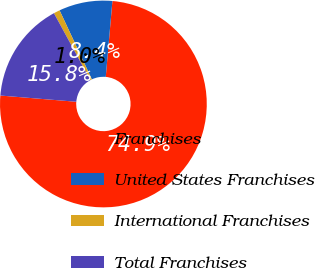Convert chart to OTSL. <chart><loc_0><loc_0><loc_500><loc_500><pie_chart><fcel>Franchises<fcel>United States Franchises<fcel>International Franchises<fcel>Total Franchises<nl><fcel>74.91%<fcel>8.36%<fcel>0.97%<fcel>15.76%<nl></chart> 